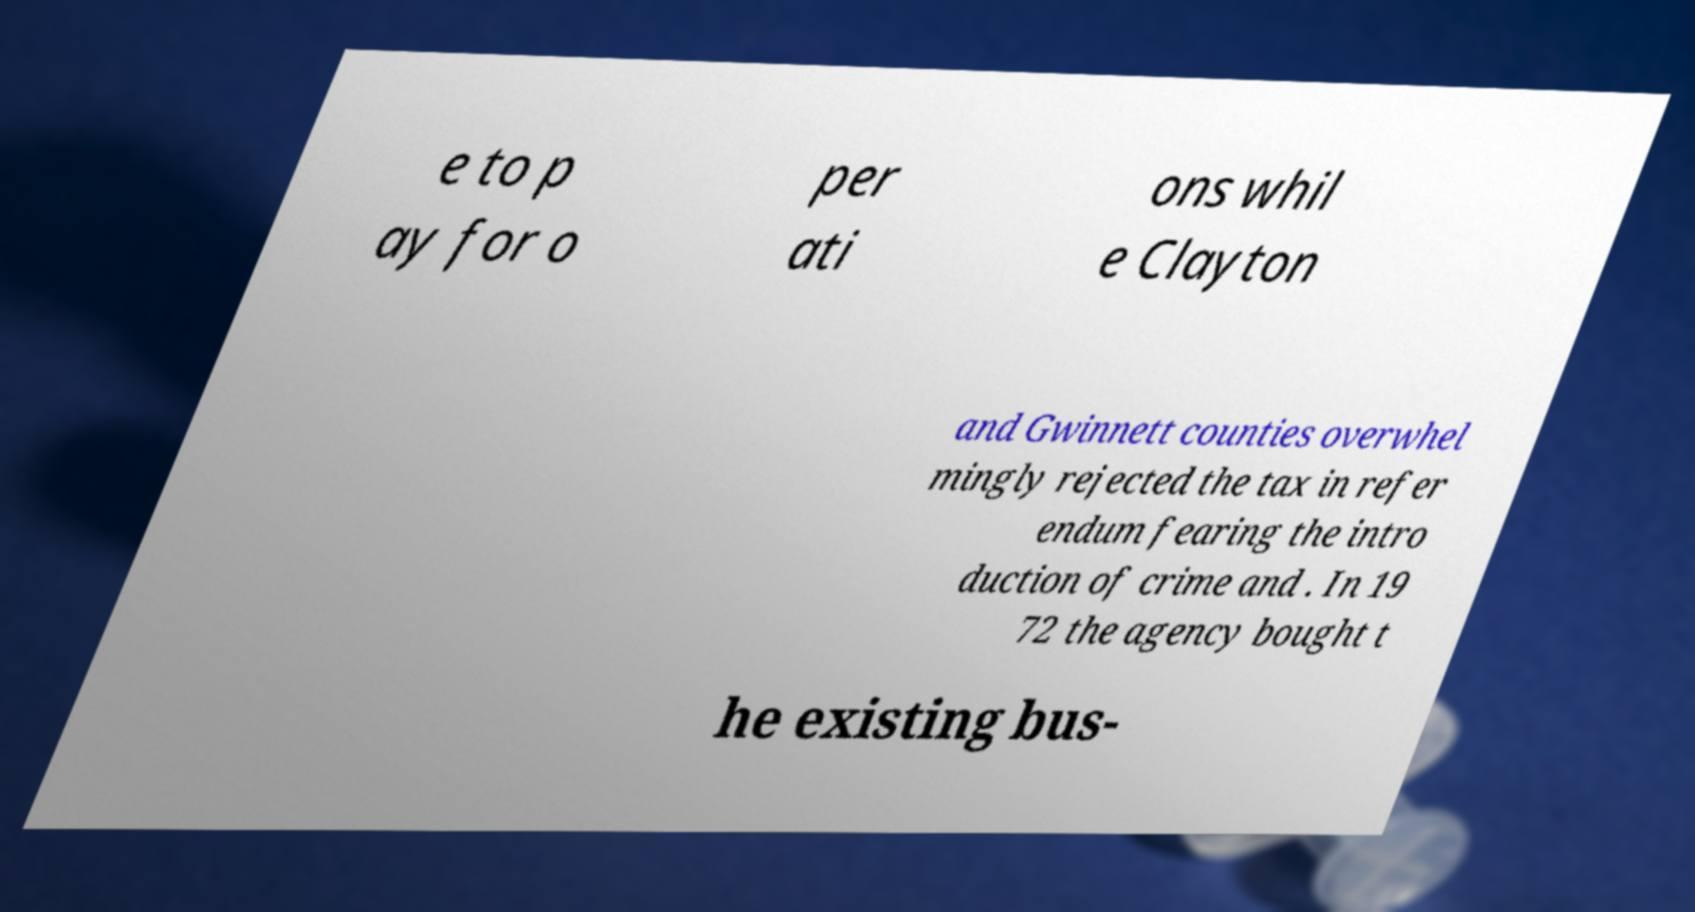Could you extract and type out the text from this image? e to p ay for o per ati ons whil e Clayton and Gwinnett counties overwhel mingly rejected the tax in refer endum fearing the intro duction of crime and . In 19 72 the agency bought t he existing bus- 